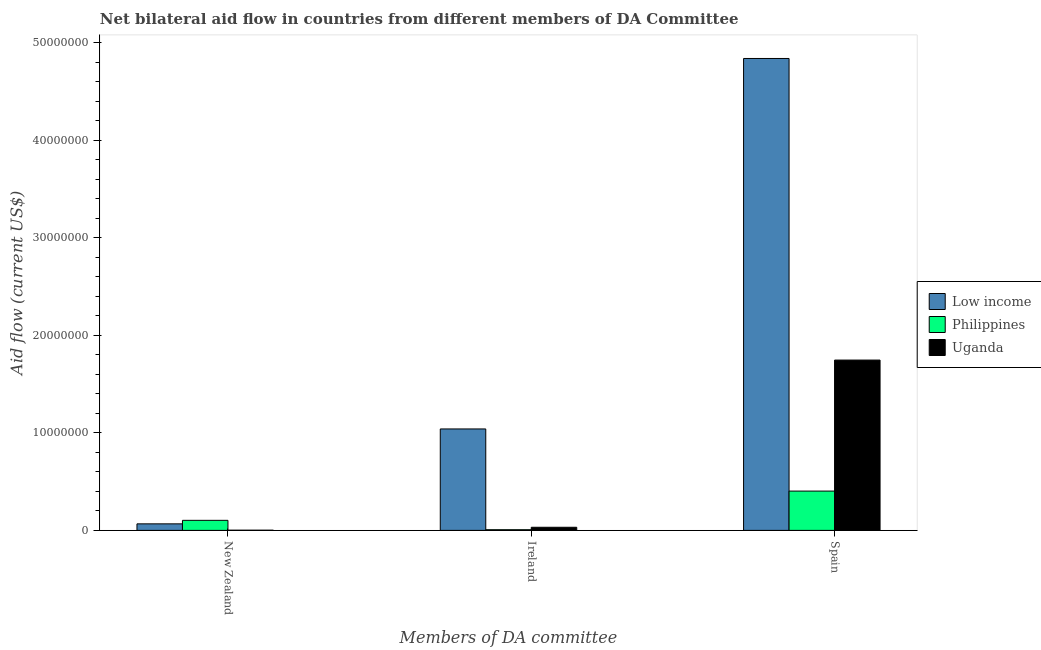How many groups of bars are there?
Offer a very short reply. 3. Are the number of bars per tick equal to the number of legend labels?
Offer a very short reply. Yes. Are the number of bars on each tick of the X-axis equal?
Offer a very short reply. Yes. How many bars are there on the 3rd tick from the left?
Give a very brief answer. 3. How many bars are there on the 2nd tick from the right?
Make the answer very short. 3. What is the label of the 2nd group of bars from the left?
Keep it short and to the point. Ireland. What is the amount of aid provided by new zealand in Uganda?
Offer a very short reply. 2.00e+04. Across all countries, what is the maximum amount of aid provided by new zealand?
Offer a terse response. 1.03e+06. Across all countries, what is the minimum amount of aid provided by new zealand?
Ensure brevity in your answer.  2.00e+04. In which country was the amount of aid provided by spain minimum?
Offer a terse response. Philippines. What is the total amount of aid provided by new zealand in the graph?
Keep it short and to the point. 1.72e+06. What is the difference between the amount of aid provided by spain in Philippines and that in Low income?
Make the answer very short. -4.44e+07. What is the difference between the amount of aid provided by ireland in Low income and the amount of aid provided by new zealand in Philippines?
Provide a short and direct response. 9.37e+06. What is the average amount of aid provided by new zealand per country?
Ensure brevity in your answer.  5.73e+05. What is the difference between the amount of aid provided by new zealand and amount of aid provided by ireland in Philippines?
Give a very brief answer. 9.60e+05. In how many countries, is the amount of aid provided by spain greater than 8000000 US$?
Keep it short and to the point. 2. What is the ratio of the amount of aid provided by new zealand in Philippines to that in Uganda?
Ensure brevity in your answer.  51.5. Is the amount of aid provided by ireland in Low income less than that in Uganda?
Provide a short and direct response. No. Is the difference between the amount of aid provided by spain in Philippines and Low income greater than the difference between the amount of aid provided by ireland in Philippines and Low income?
Provide a succinct answer. No. What is the difference between the highest and the lowest amount of aid provided by ireland?
Ensure brevity in your answer.  1.03e+07. In how many countries, is the amount of aid provided by spain greater than the average amount of aid provided by spain taken over all countries?
Offer a terse response. 1. Is the sum of the amount of aid provided by ireland in Low income and Uganda greater than the maximum amount of aid provided by new zealand across all countries?
Your answer should be compact. Yes. What does the 3rd bar from the left in Spain represents?
Your answer should be compact. Uganda. What does the 1st bar from the right in New Zealand represents?
Your answer should be very brief. Uganda. How many bars are there?
Your answer should be very brief. 9. How many countries are there in the graph?
Your answer should be compact. 3. What is the difference between two consecutive major ticks on the Y-axis?
Ensure brevity in your answer.  1.00e+07. Are the values on the major ticks of Y-axis written in scientific E-notation?
Your answer should be very brief. No. Does the graph contain any zero values?
Offer a terse response. No. Does the graph contain grids?
Make the answer very short. No. What is the title of the graph?
Make the answer very short. Net bilateral aid flow in countries from different members of DA Committee. Does "New Zealand" appear as one of the legend labels in the graph?
Your answer should be compact. No. What is the label or title of the X-axis?
Provide a succinct answer. Members of DA committee. What is the Aid flow (current US$) in Low income in New Zealand?
Provide a short and direct response. 6.70e+05. What is the Aid flow (current US$) of Philippines in New Zealand?
Your response must be concise. 1.03e+06. What is the Aid flow (current US$) in Uganda in New Zealand?
Provide a succinct answer. 2.00e+04. What is the Aid flow (current US$) in Low income in Ireland?
Your answer should be compact. 1.04e+07. What is the Aid flow (current US$) in Low income in Spain?
Your answer should be compact. 4.84e+07. What is the Aid flow (current US$) in Philippines in Spain?
Keep it short and to the point. 4.03e+06. What is the Aid flow (current US$) in Uganda in Spain?
Make the answer very short. 1.75e+07. Across all Members of DA committee, what is the maximum Aid flow (current US$) in Low income?
Keep it short and to the point. 4.84e+07. Across all Members of DA committee, what is the maximum Aid flow (current US$) of Philippines?
Offer a terse response. 4.03e+06. Across all Members of DA committee, what is the maximum Aid flow (current US$) in Uganda?
Your answer should be compact. 1.75e+07. Across all Members of DA committee, what is the minimum Aid flow (current US$) of Low income?
Provide a succinct answer. 6.70e+05. What is the total Aid flow (current US$) of Low income in the graph?
Keep it short and to the point. 5.94e+07. What is the total Aid flow (current US$) in Philippines in the graph?
Your response must be concise. 5.13e+06. What is the total Aid flow (current US$) of Uganda in the graph?
Ensure brevity in your answer.  1.78e+07. What is the difference between the Aid flow (current US$) in Low income in New Zealand and that in Ireland?
Keep it short and to the point. -9.73e+06. What is the difference between the Aid flow (current US$) in Philippines in New Zealand and that in Ireland?
Provide a succinct answer. 9.60e+05. What is the difference between the Aid flow (current US$) of Uganda in New Zealand and that in Ireland?
Ensure brevity in your answer.  -3.00e+05. What is the difference between the Aid flow (current US$) in Low income in New Zealand and that in Spain?
Offer a terse response. -4.77e+07. What is the difference between the Aid flow (current US$) in Philippines in New Zealand and that in Spain?
Offer a very short reply. -3.00e+06. What is the difference between the Aid flow (current US$) of Uganda in New Zealand and that in Spain?
Ensure brevity in your answer.  -1.74e+07. What is the difference between the Aid flow (current US$) in Low income in Ireland and that in Spain?
Keep it short and to the point. -3.80e+07. What is the difference between the Aid flow (current US$) in Philippines in Ireland and that in Spain?
Offer a terse response. -3.96e+06. What is the difference between the Aid flow (current US$) of Uganda in Ireland and that in Spain?
Your answer should be very brief. -1.71e+07. What is the difference between the Aid flow (current US$) of Low income in New Zealand and the Aid flow (current US$) of Philippines in Ireland?
Your response must be concise. 6.00e+05. What is the difference between the Aid flow (current US$) in Philippines in New Zealand and the Aid flow (current US$) in Uganda in Ireland?
Your answer should be very brief. 7.10e+05. What is the difference between the Aid flow (current US$) of Low income in New Zealand and the Aid flow (current US$) of Philippines in Spain?
Your response must be concise. -3.36e+06. What is the difference between the Aid flow (current US$) of Low income in New Zealand and the Aid flow (current US$) of Uganda in Spain?
Offer a very short reply. -1.68e+07. What is the difference between the Aid flow (current US$) of Philippines in New Zealand and the Aid flow (current US$) of Uganda in Spain?
Provide a short and direct response. -1.64e+07. What is the difference between the Aid flow (current US$) of Low income in Ireland and the Aid flow (current US$) of Philippines in Spain?
Keep it short and to the point. 6.37e+06. What is the difference between the Aid flow (current US$) in Low income in Ireland and the Aid flow (current US$) in Uganda in Spain?
Make the answer very short. -7.06e+06. What is the difference between the Aid flow (current US$) of Philippines in Ireland and the Aid flow (current US$) of Uganda in Spain?
Offer a terse response. -1.74e+07. What is the average Aid flow (current US$) in Low income per Members of DA committee?
Your answer should be compact. 1.98e+07. What is the average Aid flow (current US$) of Philippines per Members of DA committee?
Your answer should be very brief. 1.71e+06. What is the average Aid flow (current US$) in Uganda per Members of DA committee?
Offer a very short reply. 5.93e+06. What is the difference between the Aid flow (current US$) of Low income and Aid flow (current US$) of Philippines in New Zealand?
Your response must be concise. -3.60e+05. What is the difference between the Aid flow (current US$) in Low income and Aid flow (current US$) in Uganda in New Zealand?
Provide a short and direct response. 6.50e+05. What is the difference between the Aid flow (current US$) of Philippines and Aid flow (current US$) of Uganda in New Zealand?
Give a very brief answer. 1.01e+06. What is the difference between the Aid flow (current US$) of Low income and Aid flow (current US$) of Philippines in Ireland?
Offer a terse response. 1.03e+07. What is the difference between the Aid flow (current US$) of Low income and Aid flow (current US$) of Uganda in Ireland?
Provide a short and direct response. 1.01e+07. What is the difference between the Aid flow (current US$) of Philippines and Aid flow (current US$) of Uganda in Ireland?
Offer a very short reply. -2.50e+05. What is the difference between the Aid flow (current US$) in Low income and Aid flow (current US$) in Philippines in Spain?
Ensure brevity in your answer.  4.44e+07. What is the difference between the Aid flow (current US$) of Low income and Aid flow (current US$) of Uganda in Spain?
Keep it short and to the point. 3.09e+07. What is the difference between the Aid flow (current US$) of Philippines and Aid flow (current US$) of Uganda in Spain?
Ensure brevity in your answer.  -1.34e+07. What is the ratio of the Aid flow (current US$) of Low income in New Zealand to that in Ireland?
Make the answer very short. 0.06. What is the ratio of the Aid flow (current US$) in Philippines in New Zealand to that in Ireland?
Your answer should be compact. 14.71. What is the ratio of the Aid flow (current US$) in Uganda in New Zealand to that in Ireland?
Keep it short and to the point. 0.06. What is the ratio of the Aid flow (current US$) of Low income in New Zealand to that in Spain?
Keep it short and to the point. 0.01. What is the ratio of the Aid flow (current US$) in Philippines in New Zealand to that in Spain?
Provide a succinct answer. 0.26. What is the ratio of the Aid flow (current US$) of Uganda in New Zealand to that in Spain?
Ensure brevity in your answer.  0. What is the ratio of the Aid flow (current US$) in Low income in Ireland to that in Spain?
Give a very brief answer. 0.21. What is the ratio of the Aid flow (current US$) of Philippines in Ireland to that in Spain?
Ensure brevity in your answer.  0.02. What is the ratio of the Aid flow (current US$) in Uganda in Ireland to that in Spain?
Offer a terse response. 0.02. What is the difference between the highest and the second highest Aid flow (current US$) in Low income?
Provide a succinct answer. 3.80e+07. What is the difference between the highest and the second highest Aid flow (current US$) of Philippines?
Offer a very short reply. 3.00e+06. What is the difference between the highest and the second highest Aid flow (current US$) of Uganda?
Offer a terse response. 1.71e+07. What is the difference between the highest and the lowest Aid flow (current US$) in Low income?
Make the answer very short. 4.77e+07. What is the difference between the highest and the lowest Aid flow (current US$) in Philippines?
Your answer should be very brief. 3.96e+06. What is the difference between the highest and the lowest Aid flow (current US$) in Uganda?
Give a very brief answer. 1.74e+07. 